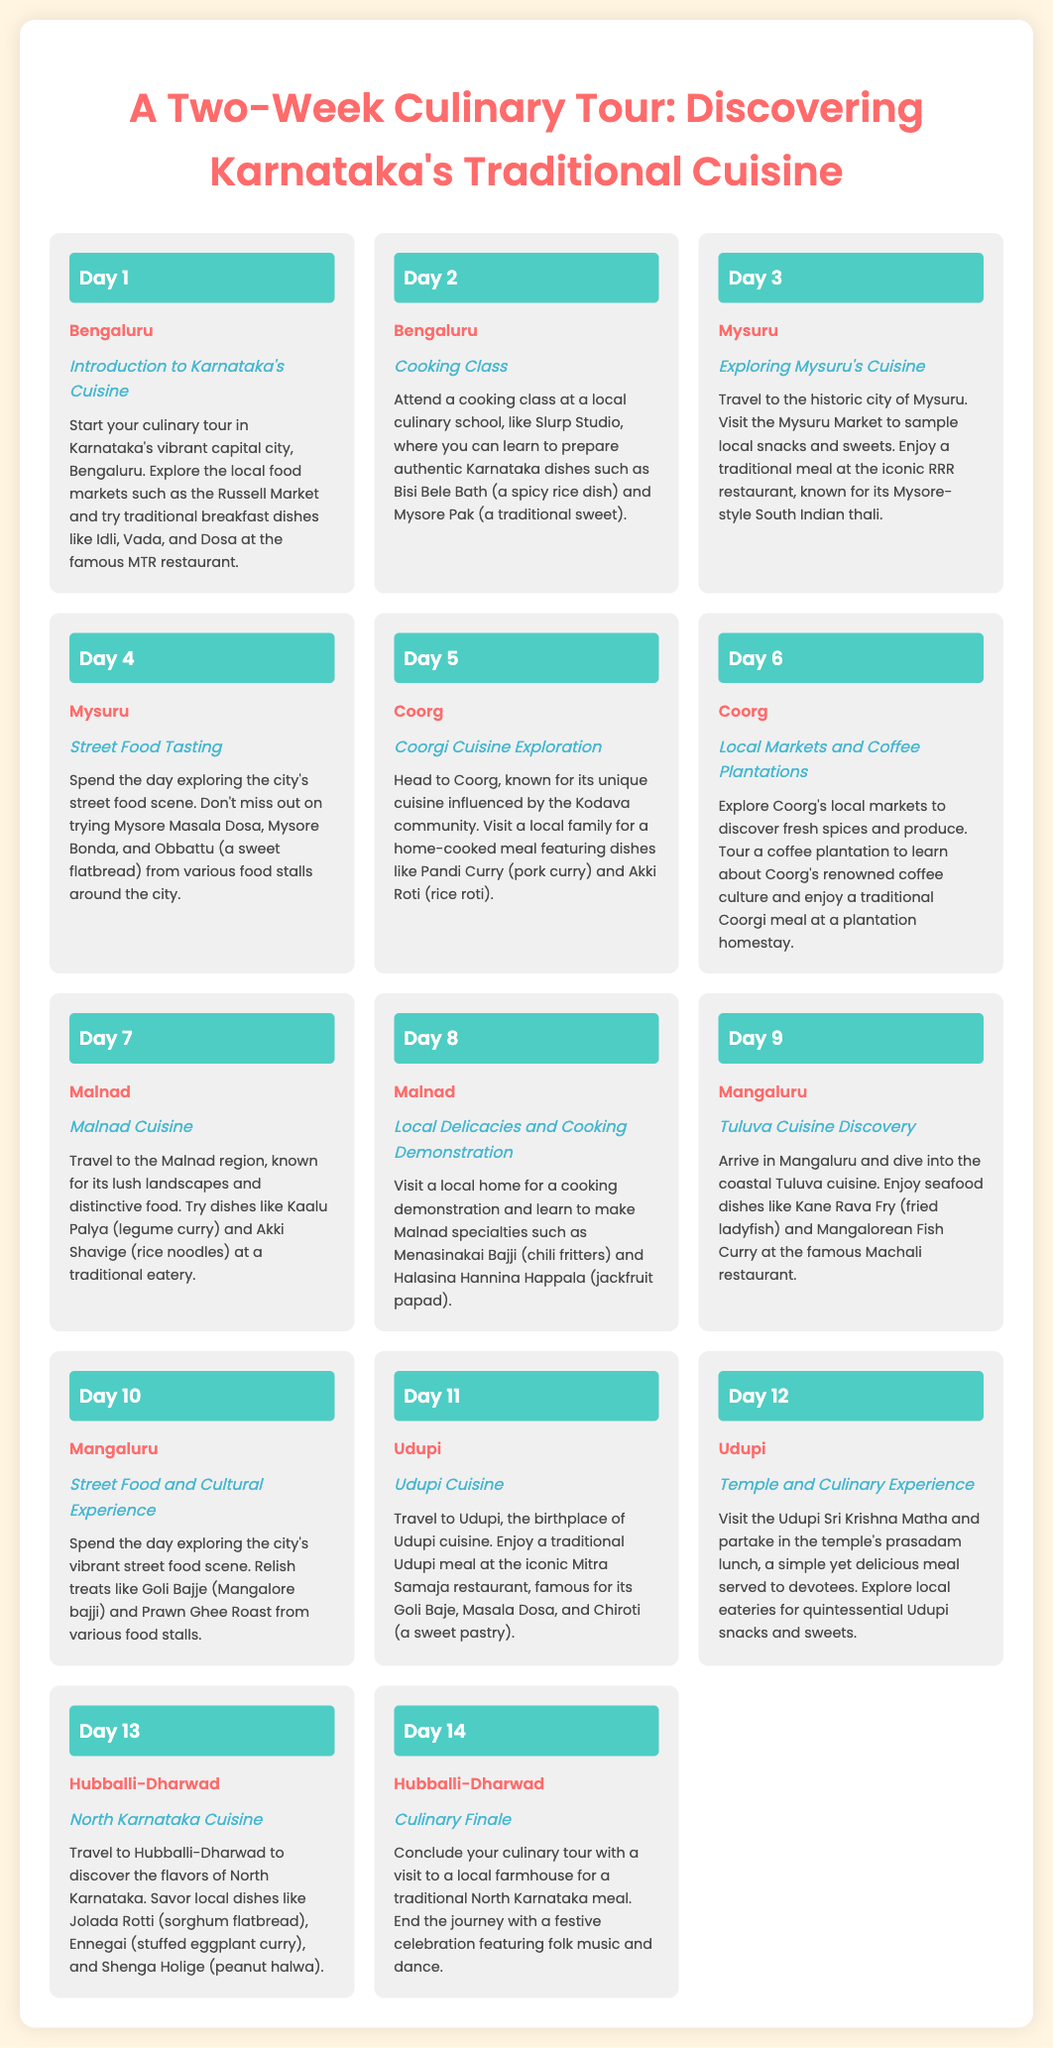What is the starting city of the culinary tour? The starting city of the culinary tour is mentioned in Day 1 of the itinerary, which lists Bengaluru as the location.
Answer: Bengaluru How many days does the tour last? The itinerary lists activities for fourteen different days, indicating the total duration of the tour.
Answer: 14 What is a traditional dish learned in the cooking class? The cooking class on Day 2 focuses on two specific dishes: Bisi Bele Bath and Mysore Pak.
Answer: Bisi Bele Bath Which city is known for street food tasting? The itinerary points out Day 4 for street food tasting activities, specifically highlighting Mysuru as the location.
Answer: Mysuru What unique meal is explored in Coorg? On Day 5, the tour highlights a unique home-cooked meal featuring Pandi Curry.
Answer: Pandi Curry What is the final day activity of the tour? The last day activities include a traditional North Karnataka meal at a local farmhouse, as outlined in Day 14.
Answer: Culinary Finale Where can the seafood dish Kane Rava Fry be enjoyed? Mangaluru is the city mentioned in Day 9 where Kane Rava Fry is enjoyed at the Machali restaurant.
Answer: Mangaluru What sweet dish is associated with Udupi cuisine? The itinerary specifies that Chiroti is a sweet pastry associated with Udupi cuisine, enjoyed at the Mitra Samaja restaurant.
Answer: Chiroti Which region is associated with the dish Jolada Rotti? The itinerary indicates that Hubballi-Dharwad is related to the dish Jolada Rotti in Day 13.
Answer: Hubballi-Dharwad 